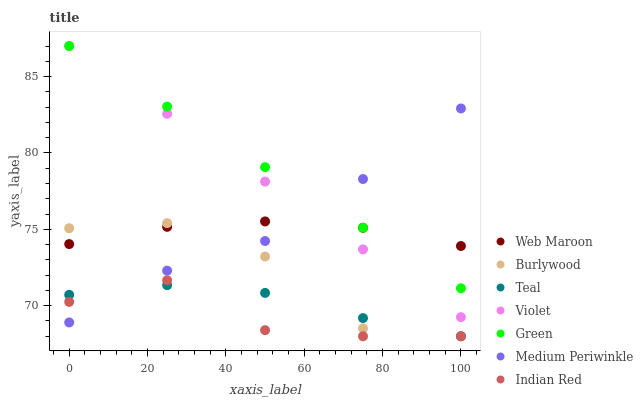Does Indian Red have the minimum area under the curve?
Answer yes or no. Yes. Does Green have the maximum area under the curve?
Answer yes or no. Yes. Does Burlywood have the minimum area under the curve?
Answer yes or no. No. Does Burlywood have the maximum area under the curve?
Answer yes or no. No. Is Violet the smoothest?
Answer yes or no. Yes. Is Burlywood the roughest?
Answer yes or no. Yes. Is Medium Periwinkle the smoothest?
Answer yes or no. No. Is Medium Periwinkle the roughest?
Answer yes or no. No. Does Indian Red have the lowest value?
Answer yes or no. Yes. Does Medium Periwinkle have the lowest value?
Answer yes or no. No. Does Violet have the highest value?
Answer yes or no. Yes. Does Burlywood have the highest value?
Answer yes or no. No. Is Burlywood less than Violet?
Answer yes or no. Yes. Is Green greater than Burlywood?
Answer yes or no. Yes. Does Teal intersect Burlywood?
Answer yes or no. Yes. Is Teal less than Burlywood?
Answer yes or no. No. Is Teal greater than Burlywood?
Answer yes or no. No. Does Burlywood intersect Violet?
Answer yes or no. No. 